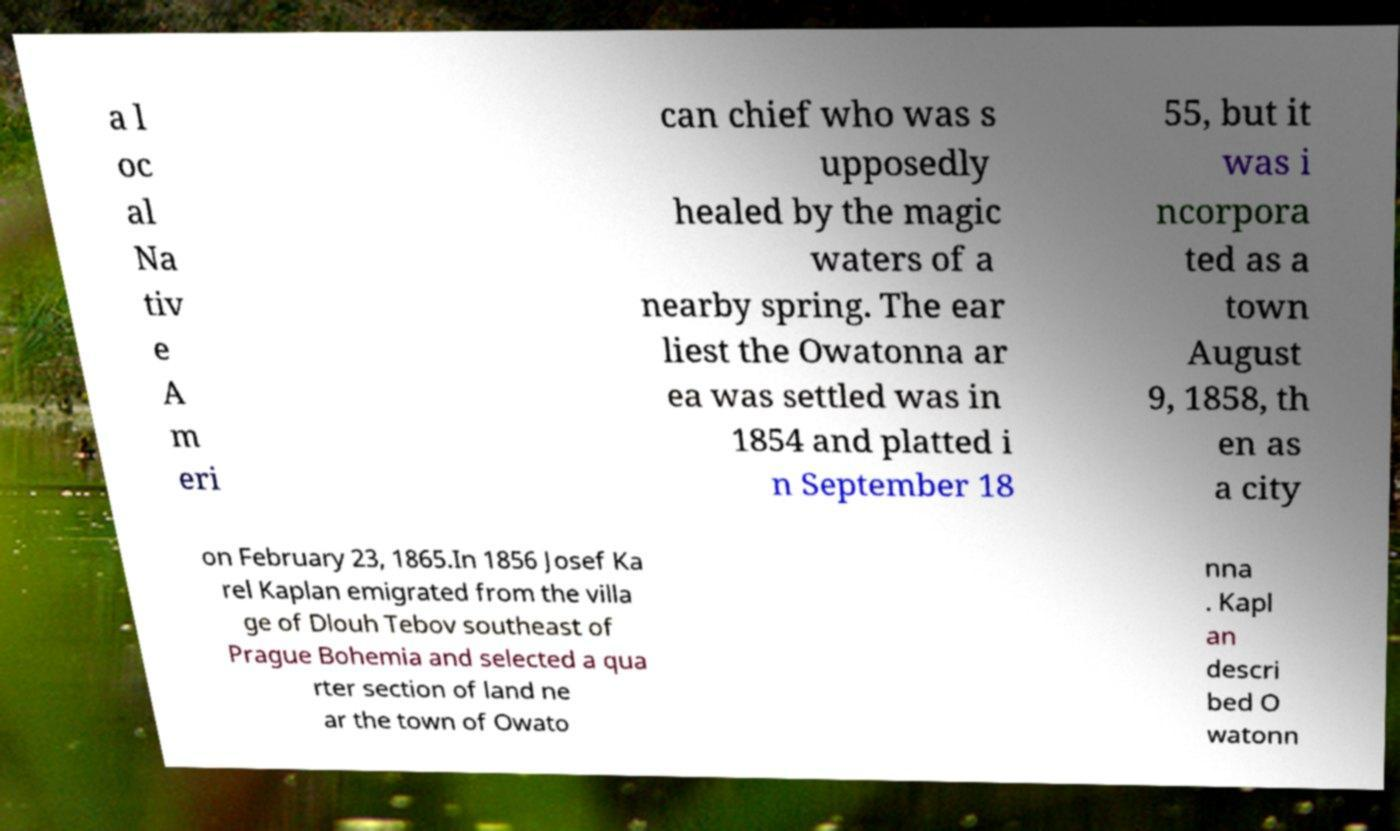Please identify and transcribe the text found in this image. a l oc al Na tiv e A m eri can chief who was s upposedly healed by the magic waters of a nearby spring. The ear liest the Owatonna ar ea was settled was in 1854 and platted i n September 18 55, but it was i ncorpora ted as a town August 9, 1858, th en as a city on February 23, 1865.In 1856 Josef Ka rel Kaplan emigrated from the villa ge of Dlouh Tebov southeast of Prague Bohemia and selected a qua rter section of land ne ar the town of Owato nna . Kapl an descri bed O watonn 